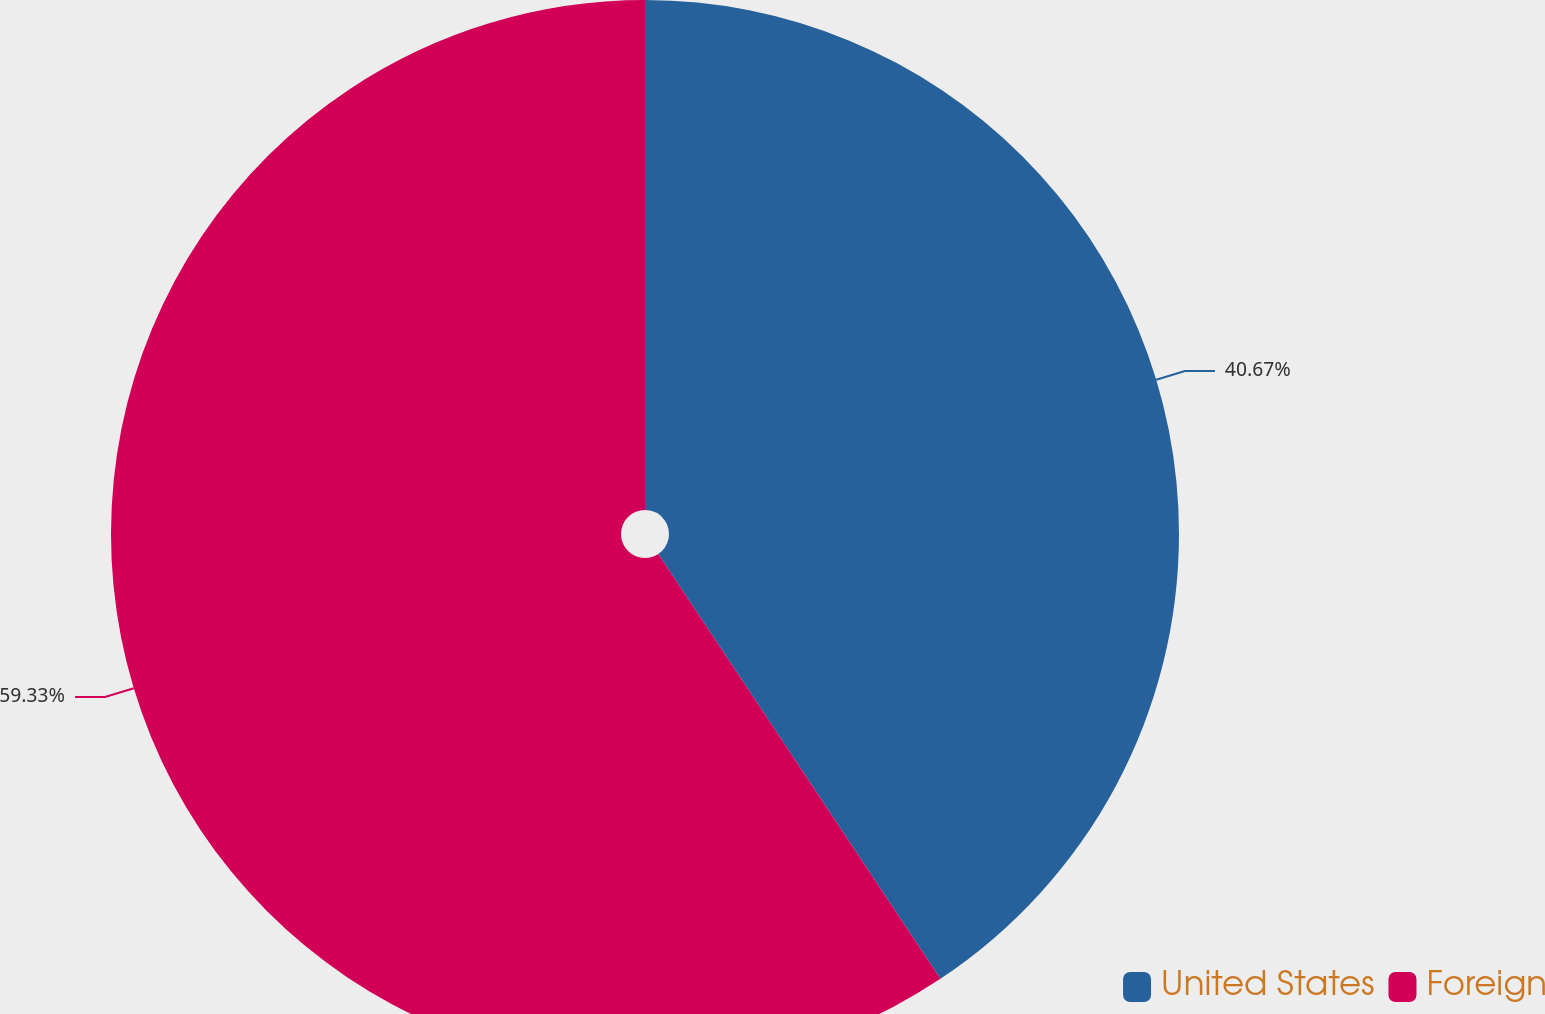Convert chart to OTSL. <chart><loc_0><loc_0><loc_500><loc_500><pie_chart><fcel>United States<fcel>Foreign<nl><fcel>40.67%<fcel>59.33%<nl></chart> 